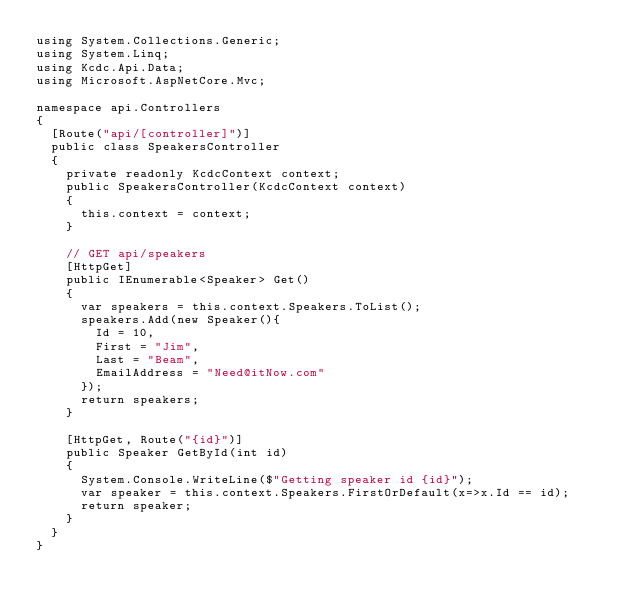<code> <loc_0><loc_0><loc_500><loc_500><_C#_>using System.Collections.Generic;
using System.Linq;
using Kcdc.Api.Data;
using Microsoft.AspNetCore.Mvc;

namespace api.Controllers
{
  [Route("api/[controller]")]
  public class SpeakersController
  {
    private readonly KcdcContext context;
    public SpeakersController(KcdcContext context)
    {
      this.context = context;
    }

    // GET api/speakers
    [HttpGet]
    public IEnumerable<Speaker> Get()
    {
      var speakers = this.context.Speakers.ToList();
      speakers.Add(new Speaker(){
        Id = 10,
        First = "Jim",
        Last = "Beam",
        EmailAddress = "Need@itNow.com"
      });
      return speakers;
    }

    [HttpGet, Route("{id}")]
    public Speaker GetById(int id)
    {
      System.Console.WriteLine($"Getting speaker id {id}");
      var speaker = this.context.Speakers.FirstOrDefault(x=>x.Id == id);
      return speaker;
    }
  }
}</code> 